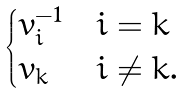<formula> <loc_0><loc_0><loc_500><loc_500>\begin{cases} v _ { i } ^ { - 1 } & i = k \\ v _ { k } & i \neq k . \end{cases}</formula> 